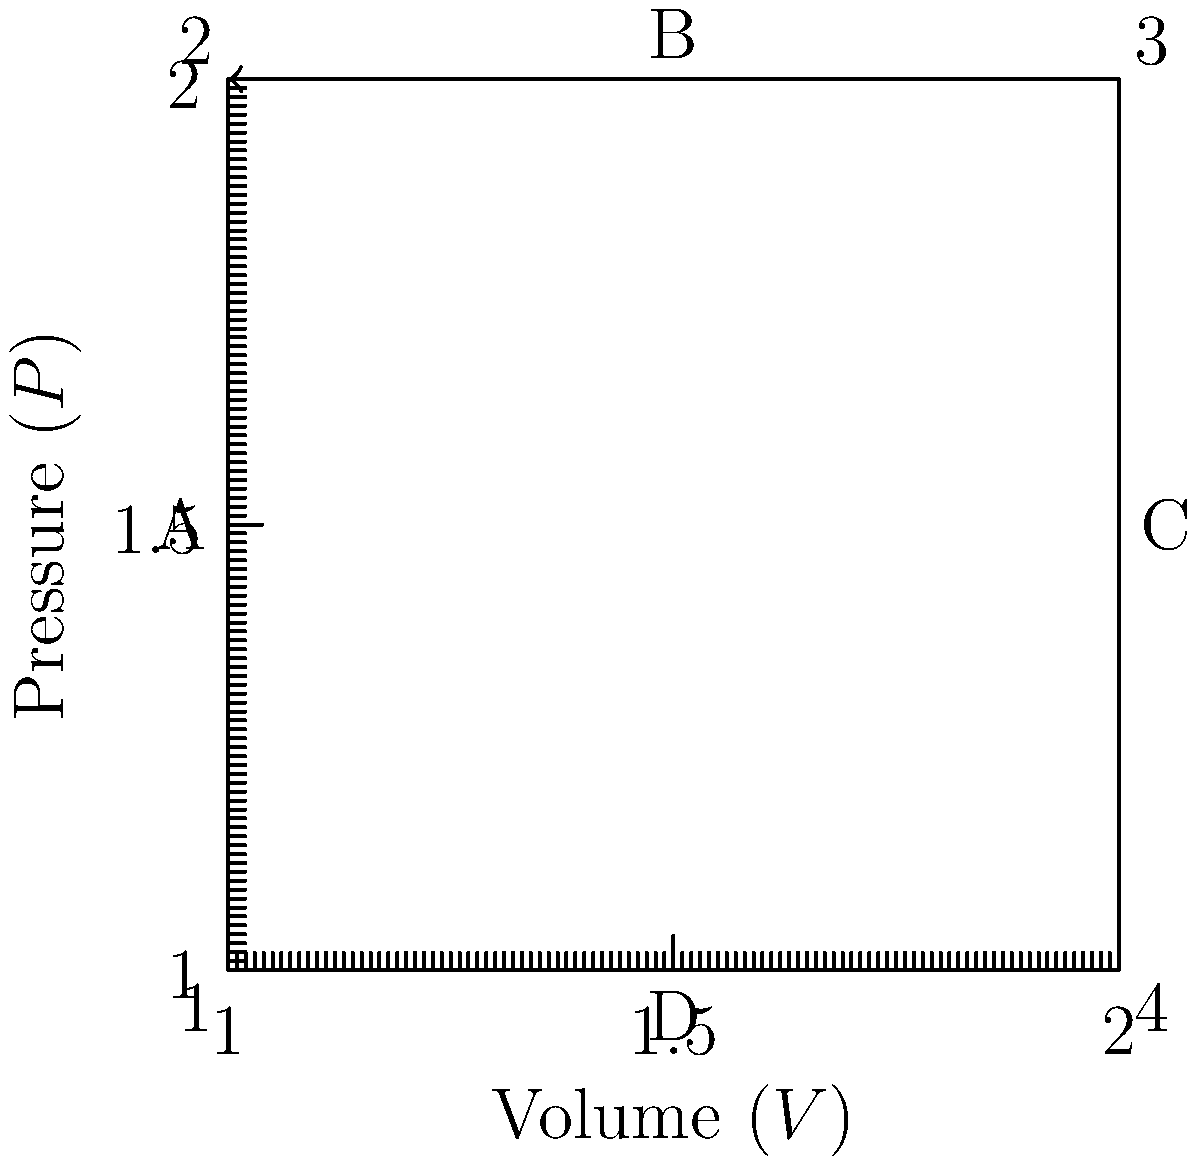As a land rights activist familiar with property boundaries, consider the enclosed area in this pressure-volume diagram as a "property". What is the total work done by the system during this thermodynamic cycle, and how does this relate to the concept of "net gain" in land transactions? To answer this question, let's approach it step-by-step:

1) In a P-V diagram, work is represented by the area enclosed by the cycle. This is analogous to how the area of a property is calculated in land rights.

2) The cycle follows a clockwise path, which means the system is doing work on the surroundings. This is similar to how a profitable land transaction results in a "net gain".

3) To calculate the work, we need to find the area of the rectangle:
   
   $W = \oint P dV = \text{Area of rectangle}$

4) The dimensions of the rectangle are:
   - Height (pressure difference): $\Delta P = 2 - 1 = 1$ unit
   - Width (volume difference): $\Delta V = 2 - 1 = 1$ unit

5) The area (work done) is therefore:
   
   $W = \Delta P \times \Delta V = 1 \times 1 = 1$ unit

6) In thermodynamics, positive work means the system is doing work on the surroundings. In land transactions, this could be likened to a profitable deal where the "system" (the land owner) gains value.

7) The clockwise direction of the cycle indicates a net positive work output, similar to how a series of land transactions resulting in a net profit would be viewed positively in property law.

This analysis demonstrates how the enclosed area in a P-V diagram represents the net work done by the system, which can be analogous to the net value gained in a series of land transactions.
Answer: 1 unit of work, representing a net positive output analogous to a profitable land transaction. 